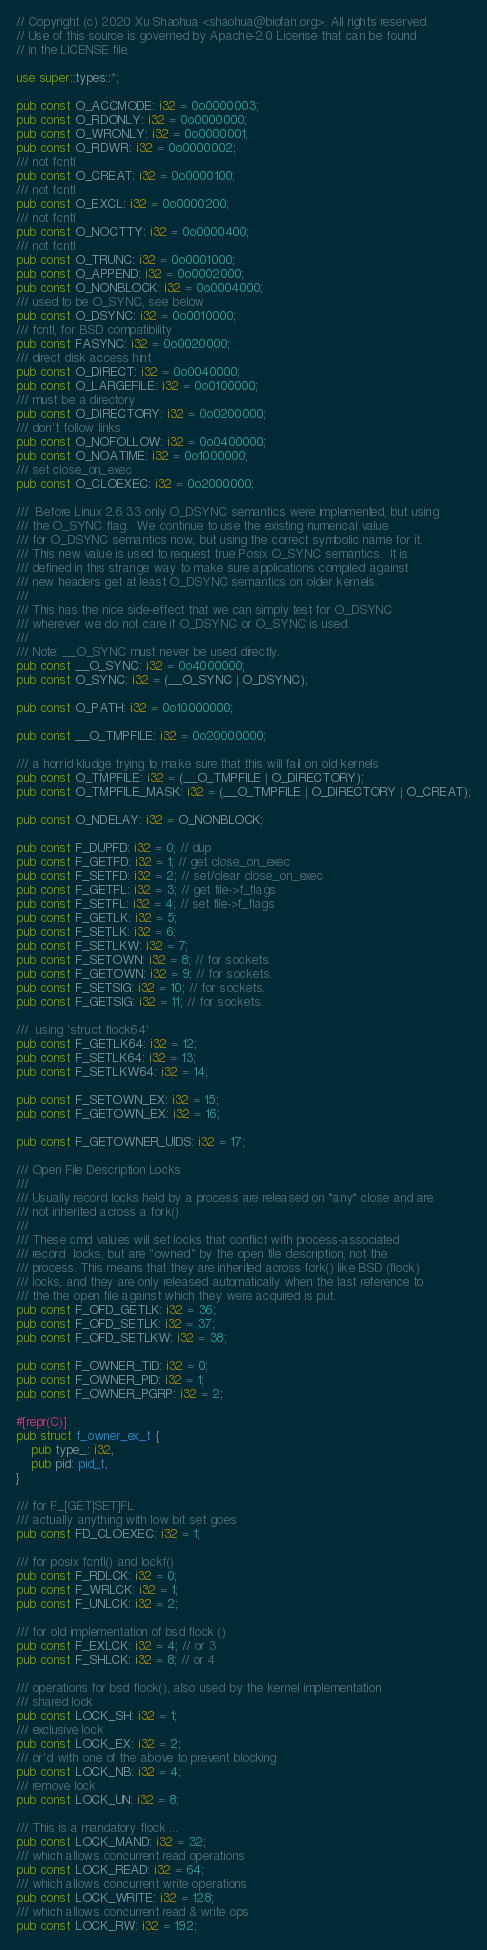Convert code to text. <code><loc_0><loc_0><loc_500><loc_500><_Rust_>// Copyright (c) 2020 Xu Shaohua <shaohua@biofan.org>. All rights reserved.
// Use of this source is governed by Apache-2.0 License that can be found
// in the LICENSE file.

use super::types::*;

pub const O_ACCMODE: i32 = 0o0000003;
pub const O_RDONLY: i32 = 0o0000000;
pub const O_WRONLY: i32 = 0o0000001;
pub const O_RDWR: i32 = 0o0000002;
/// not fcntl
pub const O_CREAT: i32 = 0o0000100;
/// not fcntl
pub const O_EXCL: i32 = 0o0000200;
/// not fcntl
pub const O_NOCTTY: i32 = 0o0000400;
/// not fcntl
pub const O_TRUNC: i32 = 0o0001000;
pub const O_APPEND: i32 = 0o0002000;
pub const O_NONBLOCK: i32 = 0o0004000;
/// used to be O_SYNC, see below
pub const O_DSYNC: i32 = 0o0010000;
/// fcntl, for BSD compatibility
pub const FASYNC: i32 = 0o0020000;
/// direct disk access hint
pub const O_DIRECT: i32 = 0o0040000;
pub const O_LARGEFILE: i32 = 0o0100000;
/// must be a directory
pub const O_DIRECTORY: i32 = 0o0200000;
/// don't follow links
pub const O_NOFOLLOW: i32 = 0o0400000;
pub const O_NOATIME: i32 = 0o1000000;
/// set close_on_exec
pub const O_CLOEXEC: i32 = 0o2000000;

///  Before Linux 2.6.33 only O_DSYNC semantics were implemented, but using
/// the O_SYNC flag.  We continue to use the existing numerical value
/// for O_DSYNC semantics now, but using the correct symbolic name for it.
/// This new value is used to request true Posix O_SYNC semantics.  It is
/// defined in this strange way to make sure applications compiled against
/// new headers get at least O_DSYNC semantics on older kernels.
///
/// This has the nice side-effect that we can simply test for O_DSYNC
/// wherever we do not care if O_DSYNC or O_SYNC is used.
///
/// Note: __O_SYNC must never be used directly.
pub const __O_SYNC: i32 = 0o4000000;
pub const O_SYNC: i32 = (__O_SYNC | O_DSYNC);

pub const O_PATH: i32 = 0o10000000;

pub const __O_TMPFILE: i32 = 0o20000000;

/// a horrid kludge trying to make sure that this will fail on old kernels
pub const O_TMPFILE: i32 = (__O_TMPFILE | O_DIRECTORY);
pub const O_TMPFILE_MASK: i32 = (__O_TMPFILE | O_DIRECTORY | O_CREAT);

pub const O_NDELAY: i32 = O_NONBLOCK;

pub const F_DUPFD: i32 = 0; // dup
pub const F_GETFD: i32 = 1; // get close_on_exec
pub const F_SETFD: i32 = 2; // set/clear close_on_exec
pub const F_GETFL: i32 = 3; // get file->f_flags
pub const F_SETFL: i32 = 4; // set file->f_flags
pub const F_GETLK: i32 = 5;
pub const F_SETLK: i32 = 6;
pub const F_SETLKW: i32 = 7;
pub const F_SETOWN: i32 = 8; // for sockets.
pub const F_GETOWN: i32 = 9; // for sockets.
pub const F_SETSIG: i32 = 10; // for sockets.
pub const F_GETSIG: i32 = 11; // for sockets.

///  using 'struct flock64'
pub const F_GETLK64: i32 = 12;
pub const F_SETLK64: i32 = 13;
pub const F_SETLKW64: i32 = 14;

pub const F_SETOWN_EX: i32 = 15;
pub const F_GETOWN_EX: i32 = 16;

pub const F_GETOWNER_UIDS: i32 = 17;

/// Open File Description Locks
///
/// Usually record locks held by a process are released on *any* close and are
/// not inherited across a fork().
///
/// These cmd values will set locks that conflict with process-associated
/// record  locks, but are "owned" by the open file description, not the
/// process. This means that they are inherited across fork() like BSD (flock)
/// locks, and they are only released automatically when the last reference to
/// the the open file against which they were acquired is put.
pub const F_OFD_GETLK: i32 = 36;
pub const F_OFD_SETLK: i32 = 37;
pub const F_OFD_SETLKW: i32 = 38;

pub const F_OWNER_TID: i32 = 0;
pub const F_OWNER_PID: i32 = 1;
pub const F_OWNER_PGRP: i32 = 2;

#[repr(C)]
pub struct f_owner_ex_t {
    pub type_: i32,
    pub pid: pid_t,
}

/// for F_[GET|SET]FL
/// actually anything with low bit set goes
pub const FD_CLOEXEC: i32 = 1;

/// for posix fcntl() and lockf()
pub const F_RDLCK: i32 = 0;
pub const F_WRLCK: i32 = 1;
pub const F_UNLCK: i32 = 2;

/// for old implementation of bsd flock ()
pub const F_EXLCK: i32 = 4; // or 3
pub const F_SHLCK: i32 = 8; // or 4

/// operations for bsd flock(), also used by the kernel implementation
/// shared lock
pub const LOCK_SH: i32 = 1;
/// exclusive lock
pub const LOCK_EX: i32 = 2;
/// or'd with one of the above to prevent blocking
pub const LOCK_NB: i32 = 4;
/// remove lock
pub const LOCK_UN: i32 = 8;

/// This is a mandatory flock ...
pub const LOCK_MAND: i32 = 32;
/// which allows concurrent read operations
pub const LOCK_READ: i32 = 64;
/// which allows concurrent write operations
pub const LOCK_WRITE: i32 = 128;
/// which allows concurrent read & write ops
pub const LOCK_RW: i32 = 192;
</code> 